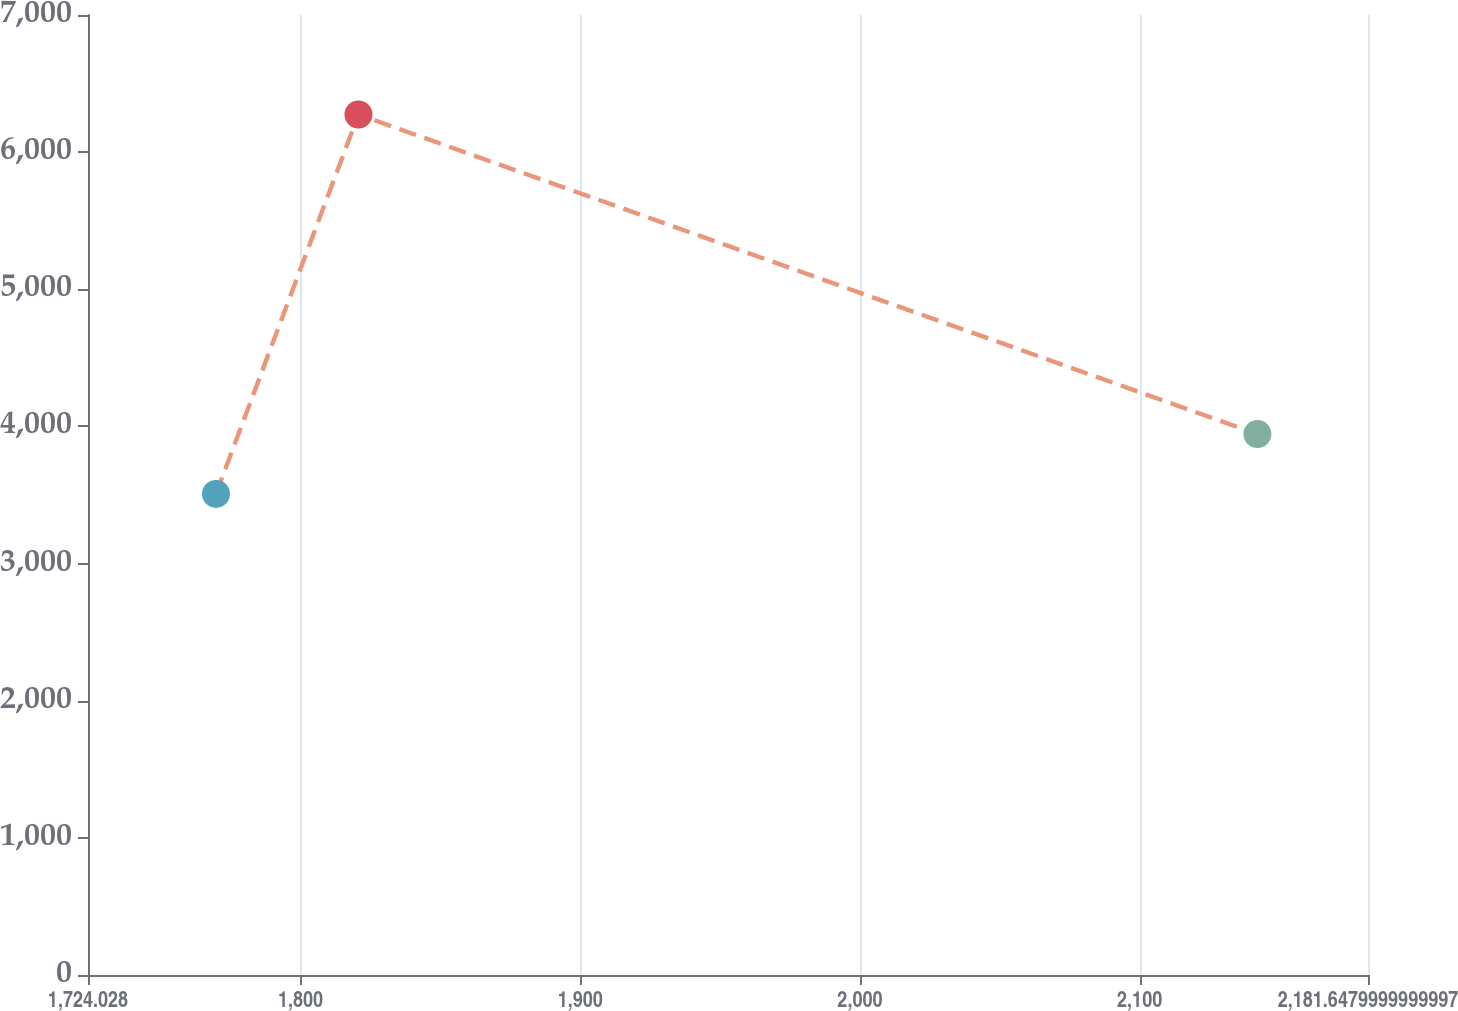Convert chart. <chart><loc_0><loc_0><loc_500><loc_500><line_chart><ecel><fcel>$ 2,500<nl><fcel>1769.79<fcel>3507.66<nl><fcel>1820.72<fcel>6274.56<nl><fcel>2142.11<fcel>3944.33<nl><fcel>2227.41<fcel>5699.97<nl></chart> 